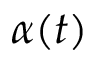<formula> <loc_0><loc_0><loc_500><loc_500>\alpha ( t )</formula> 